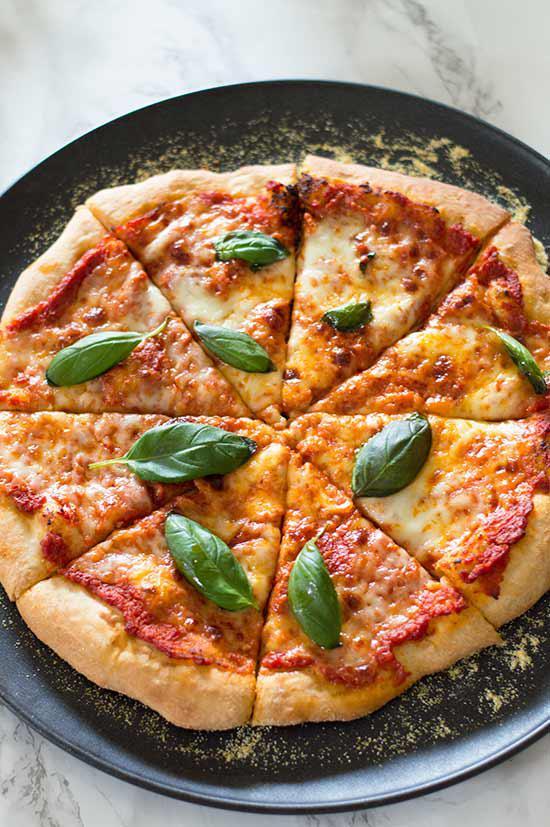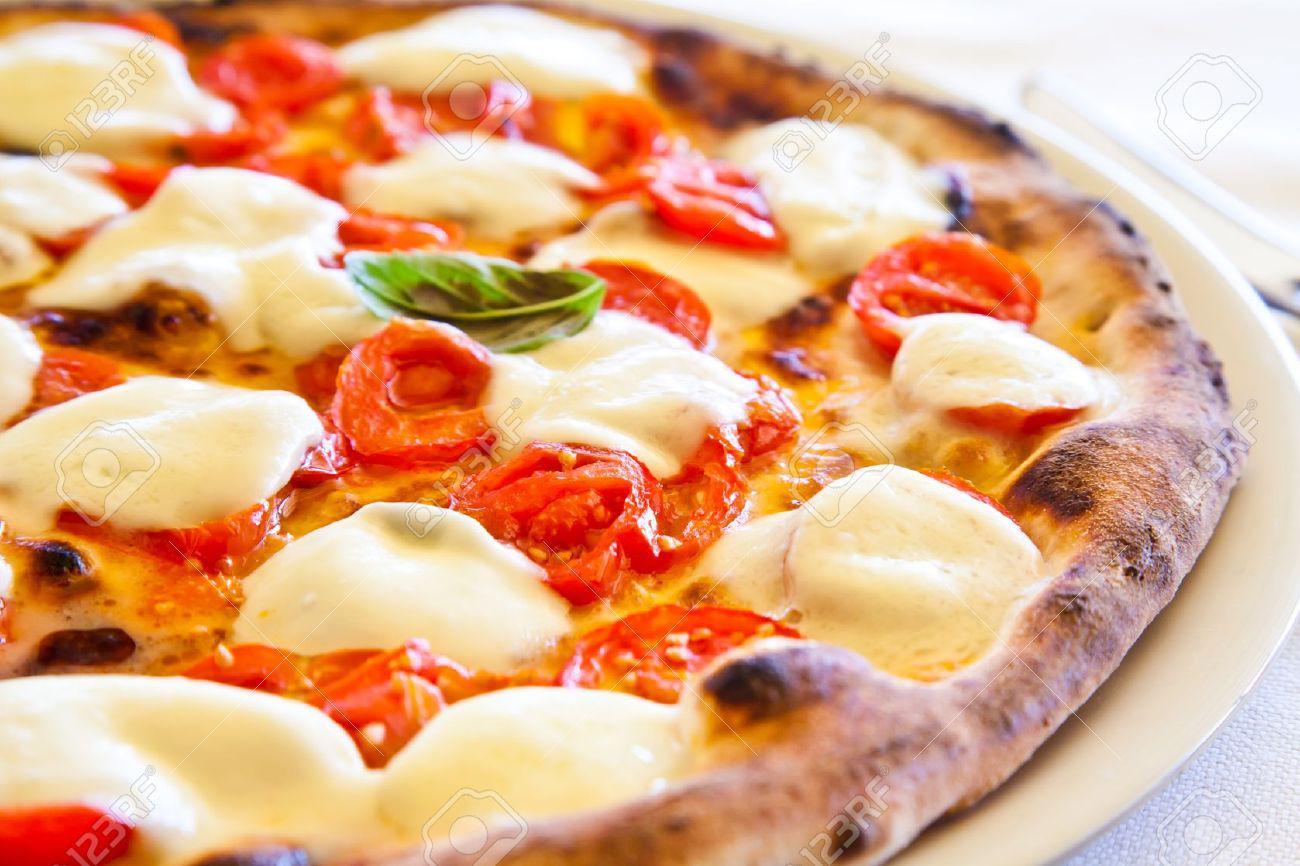The first image is the image on the left, the second image is the image on the right. Evaluate the accuracy of this statement regarding the images: "There is an uncut pizza in the right image.". Is it true? Answer yes or no. Yes. 